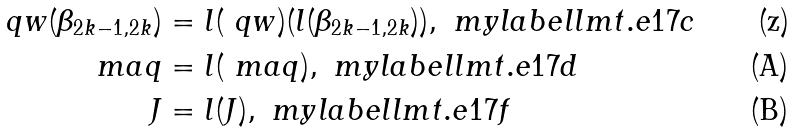Convert formula to latex. <formula><loc_0><loc_0><loc_500><loc_500>\ q w ( \beta _ { 2 k - 1 , 2 k } ) & = l ( \ q w ) ( l ( \beta _ { 2 k - 1 , 2 k } ) ) , \ m y l a b e l { l m t . e 1 7 c } \\ \ m a q & = l ( \ m a q ) , \ m y l a b e l { l m t . e 1 7 d } \\ J & = l ( J ) , \ m y l a b e l { l m t . e 1 7 f }</formula> 